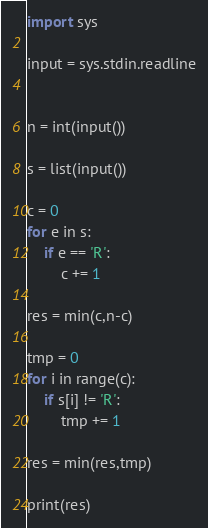Convert code to text. <code><loc_0><loc_0><loc_500><loc_500><_Python_>import sys

input = sys.stdin.readline


n = int(input())

s = list(input())

c = 0
for e in s:
    if e == 'R':
        c += 1

res = min(c,n-c)

tmp = 0
for i in range(c):
    if s[i] != 'R':
        tmp += 1

res = min(res,tmp)

print(res)
</code> 